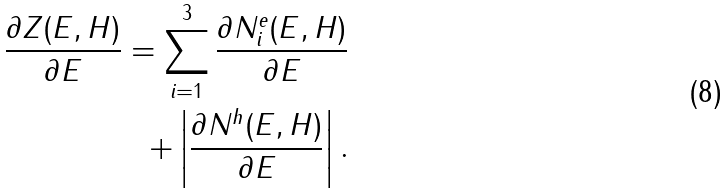Convert formula to latex. <formula><loc_0><loc_0><loc_500><loc_500>\frac { \partial Z ( E , H ) } { \partial E } = \sum _ { i = 1 } ^ { 3 } \frac { \partial N _ { i } ^ { e } ( E , H ) } { \partial E } \\ + \left | \frac { \partial N ^ { h } ( E , H ) } { \partial E } \right | .</formula> 